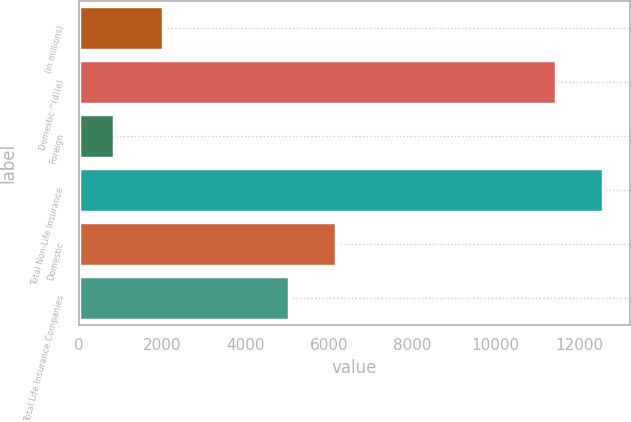<chart> <loc_0><loc_0><loc_500><loc_500><bar_chart><fcel>(in millions)<fcel>Domestic ^(d)(e)<fcel>Foreign<fcel>Total Non-Life Insurance<fcel>Domestic<fcel>Total Life Insurance Companies<nl><fcel>2013<fcel>11440<fcel>842<fcel>12584<fcel>6182<fcel>5038<nl></chart> 